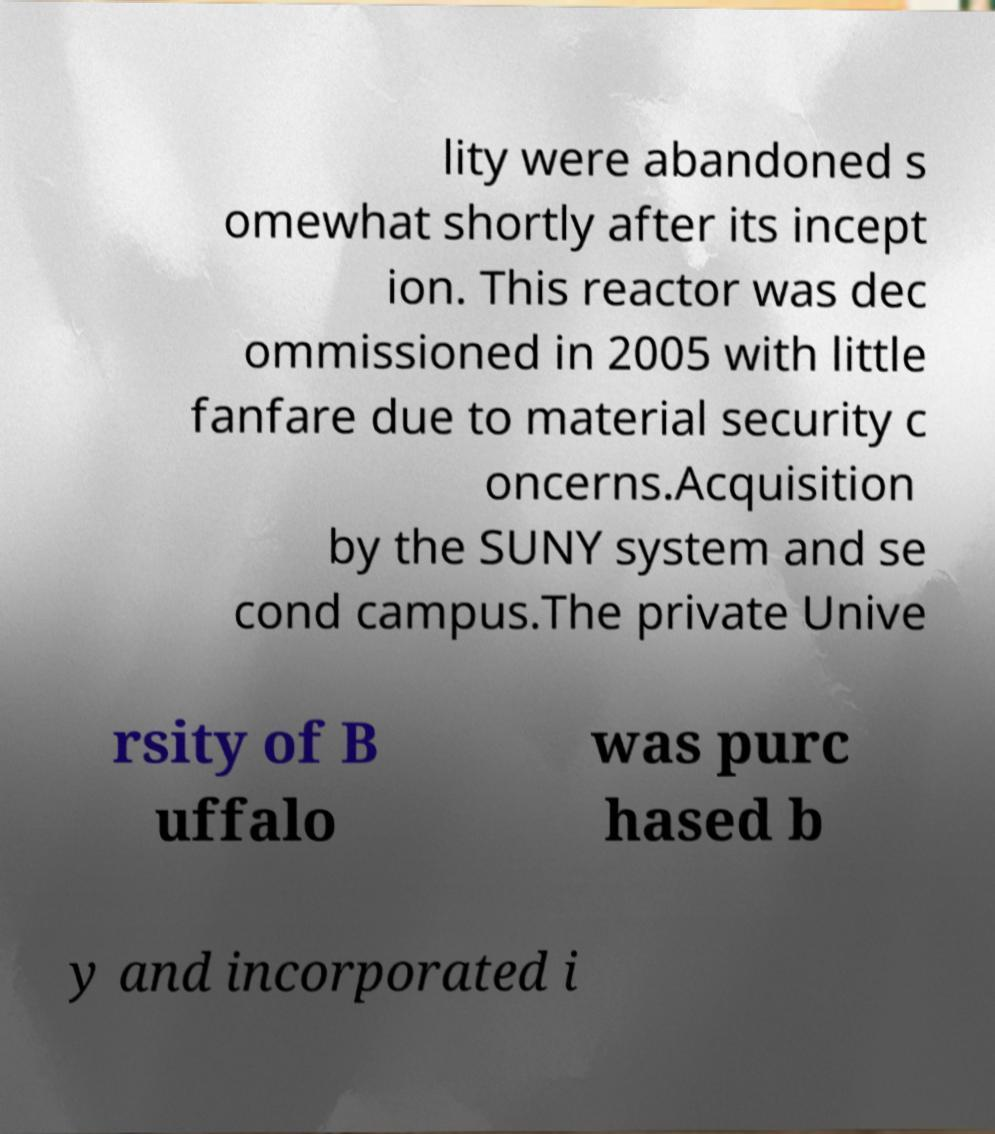I need the written content from this picture converted into text. Can you do that? lity were abandoned s omewhat shortly after its incept ion. This reactor was dec ommissioned in 2005 with little fanfare due to material security c oncerns.Acquisition by the SUNY system and se cond campus.The private Unive rsity of B uffalo was purc hased b y and incorporated i 